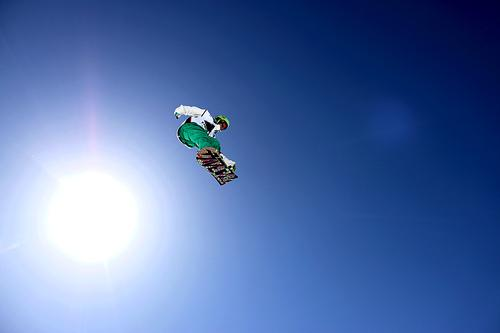Question: what color is the person's pants?
Choices:
A. Black.
B. Blue.
C. Green.
D. White.
Answer with the letter. Answer: C Question: what is on the person's head?
Choices:
A. A helmet.
B. Hair.
C. Headband.
D. Sunglasses.
Answer with the letter. Answer: A Question: when was the photo taken?
Choices:
A. Winter time.
B. High noon.
C. During the day.
D. Dusk.
Answer with the letter. Answer: C Question: how many clouds do you see?
Choices:
A. Two.
B. Three.
C. Four.
D. None.
Answer with the letter. Answer: D Question: where is the person?
Choices:
A. Sitting in chair.
B. Lying on the bed.
C. In the air.
D. In a car.
Answer with the letter. Answer: C 